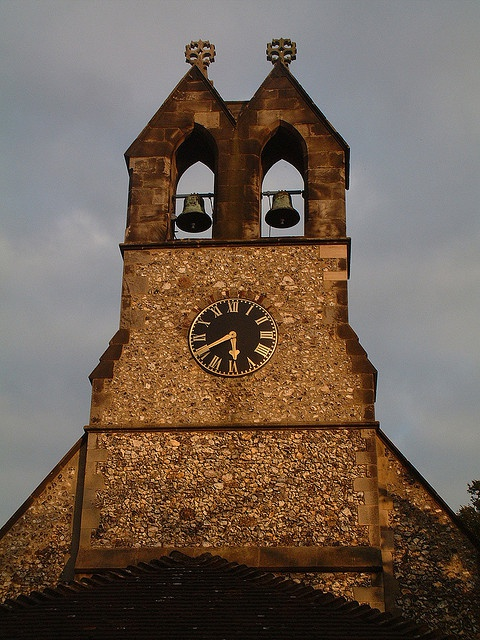Describe the objects in this image and their specific colors. I can see a clock in gray, black, maroon, tan, and khaki tones in this image. 